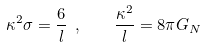Convert formula to latex. <formula><loc_0><loc_0><loc_500><loc_500>\kappa ^ { 2 } \sigma = { \frac { 6 } { l } } \ , \quad { \frac { \kappa ^ { 2 } } { l } } = 8 \pi G _ { N }</formula> 